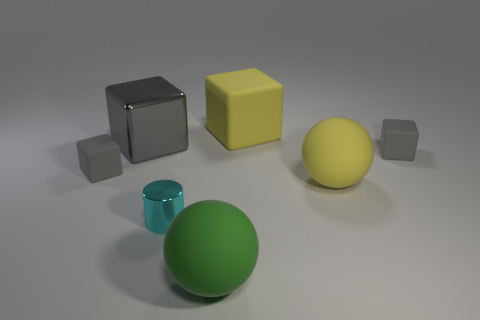Subtract all gray cubes. How many were subtracted if there are2gray cubes left? 1 Subtract all yellow cubes. How many cubes are left? 3 Subtract all gray cylinders. How many yellow balls are left? 1 Subtract all yellow balls. How many balls are left? 1 Subtract all cylinders. How many objects are left? 6 Subtract 1 cylinders. How many cylinders are left? 0 Subtract all purple blocks. Subtract all gray cylinders. How many blocks are left? 4 Subtract all gray matte things. Subtract all big green things. How many objects are left? 4 Add 1 large things. How many large things are left? 5 Add 4 tiny purple metal cylinders. How many tiny purple metal cylinders exist? 4 